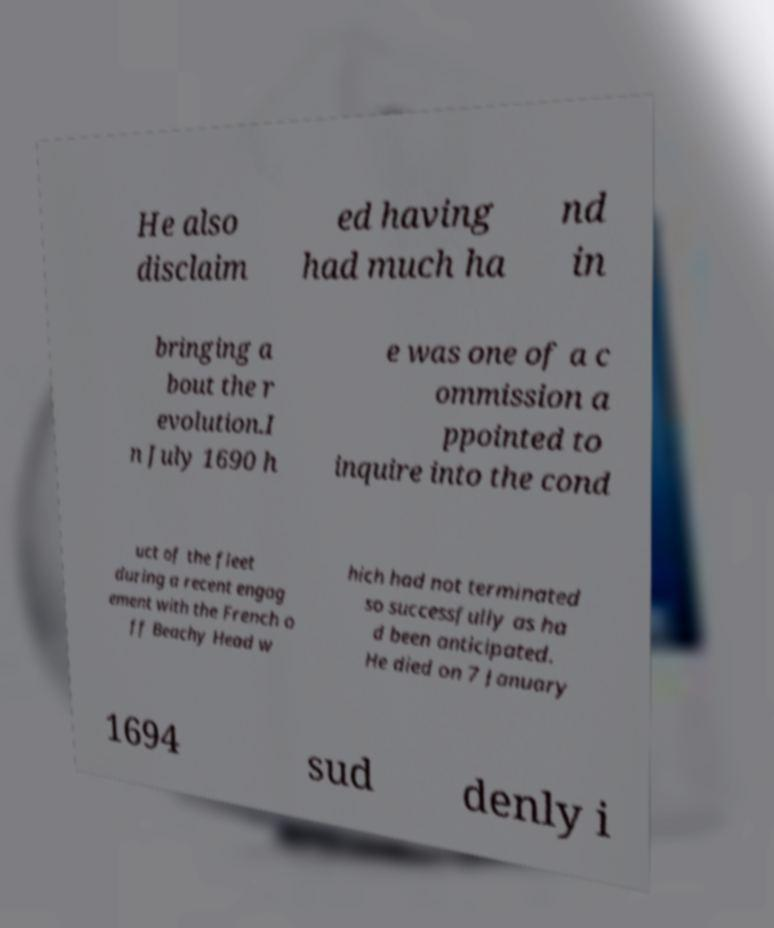For documentation purposes, I need the text within this image transcribed. Could you provide that? He also disclaim ed having had much ha nd in bringing a bout the r evolution.I n July 1690 h e was one of a c ommission a ppointed to inquire into the cond uct of the fleet during a recent engag ement with the French o ff Beachy Head w hich had not terminated so successfully as ha d been anticipated. He died on 7 January 1694 sud denly i 